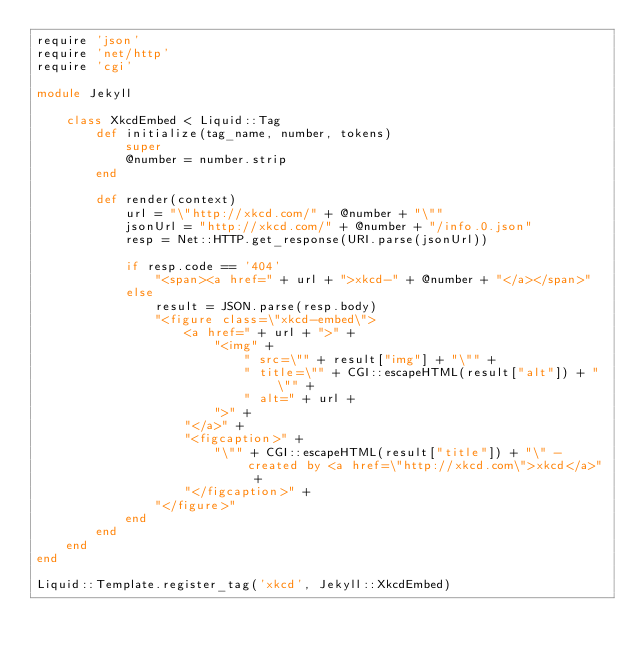<code> <loc_0><loc_0><loc_500><loc_500><_Ruby_>require 'json'
require 'net/http'
require 'cgi'

module Jekyll

	class XkcdEmbed < Liquid::Tag
		def	initialize(tag_name, number, tokens)
			super
			@number = number.strip
		end
		
		def render(context)
			url = "\"http://xkcd.com/" + @number + "\""
			jsonUrl = "http://xkcd.com/" + @number + "/info.0.json"
			resp = Net::HTTP.get_response(URI.parse(jsonUrl))			
			
			if resp.code == '404'
				"<span><a href=" + url + ">xkcd-" + @number + "</a></span>"
			else	
				result = JSON.parse(resp.body)
				"<figure class=\"xkcd-embed\">
					<a href=" + url + ">" + 
						"<img" + 
							" src=\"" + result["img"] + "\"" + 
							" title=\"" + CGI::escapeHTML(result["alt"]) + "\"" + 
							" alt=" + url + 
						">" +
					"</a>" + 
					"<figcaption>" +
						"\"" + CGI::escapeHTML(result["title"]) + "\" - created by <a href=\"http://xkcd.com\">xkcd</a>" + 
					"</figcaption>" +
				"</figure>"
			end
		end
	end
end

Liquid::Template.register_tag('xkcd', Jekyll::XkcdEmbed)
</code> 